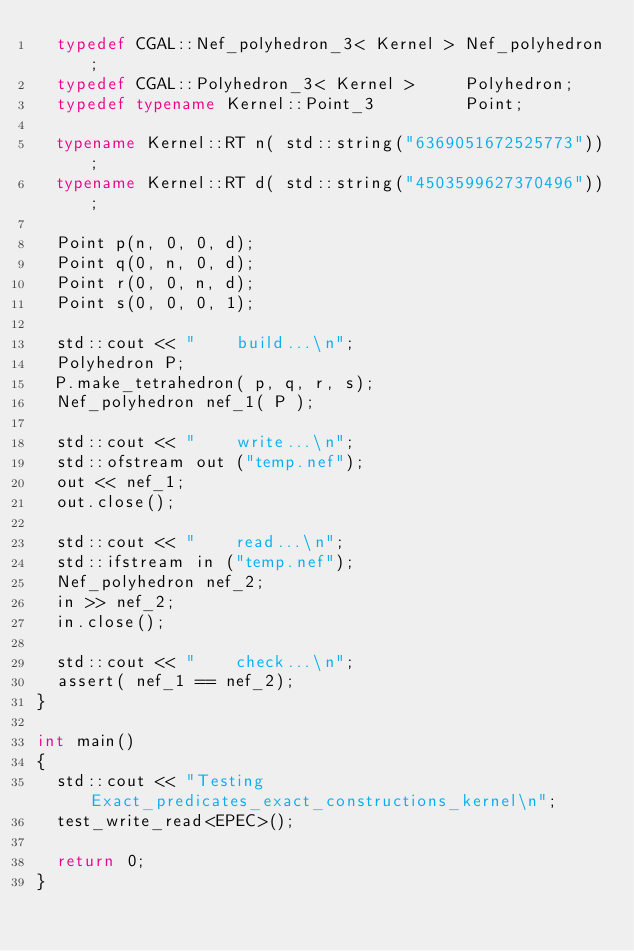<code> <loc_0><loc_0><loc_500><loc_500><_C++_>  typedef CGAL::Nef_polyhedron_3< Kernel > Nef_polyhedron;
  typedef CGAL::Polyhedron_3< Kernel >     Polyhedron;
  typedef typename Kernel::Point_3         Point;

  typename Kernel::RT n( std::string("6369051672525773"));
  typename Kernel::RT d( std::string("4503599627370496"));

  Point p(n, 0, 0, d);
  Point q(0, n, 0, d);
  Point r(0, 0, n, d);
  Point s(0, 0, 0, 1);

  std::cout << "    build...\n";
  Polyhedron P;
  P.make_tetrahedron( p, q, r, s);
  Nef_polyhedron nef_1( P );

  std::cout << "    write...\n";
  std::ofstream out ("temp.nef");
  out << nef_1;
  out.close();

  std::cout << "    read...\n";
  std::ifstream in ("temp.nef");
  Nef_polyhedron nef_2;
  in >> nef_2;
  in.close();

  std::cout << "    check...\n";
  assert( nef_1 == nef_2);
}

int main()
{
  std::cout << "Testing Exact_predicates_exact_constructions_kernel\n";
  test_write_read<EPEC>();
 
  return 0;
}
</code> 